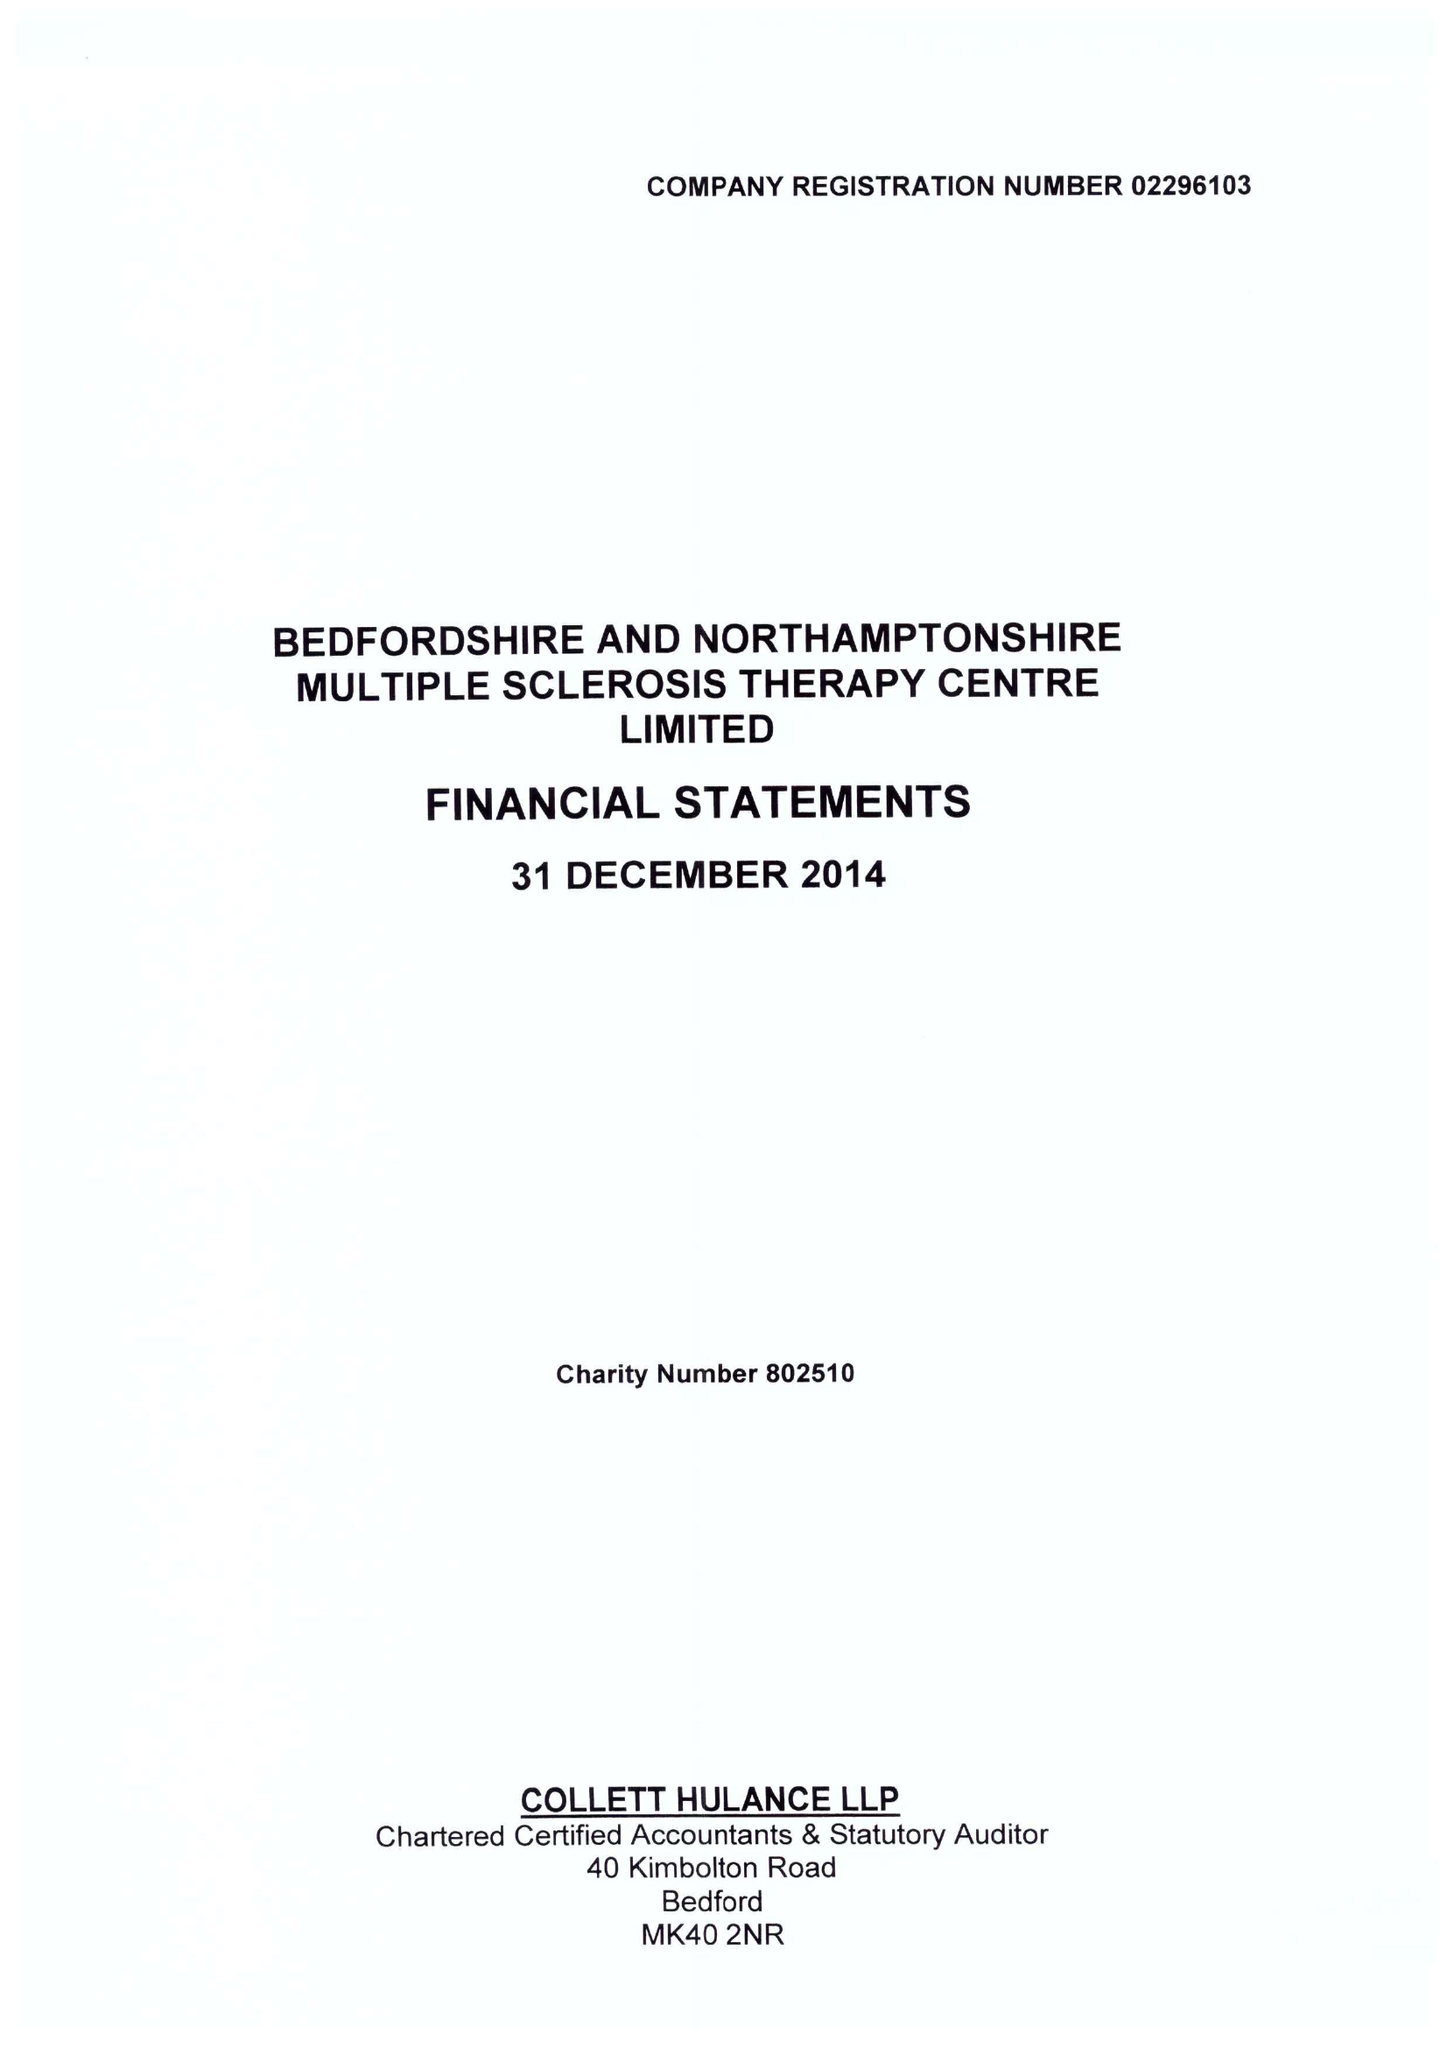What is the value for the address__post_town?
Answer the question using a single word or phrase. BEDFORD 